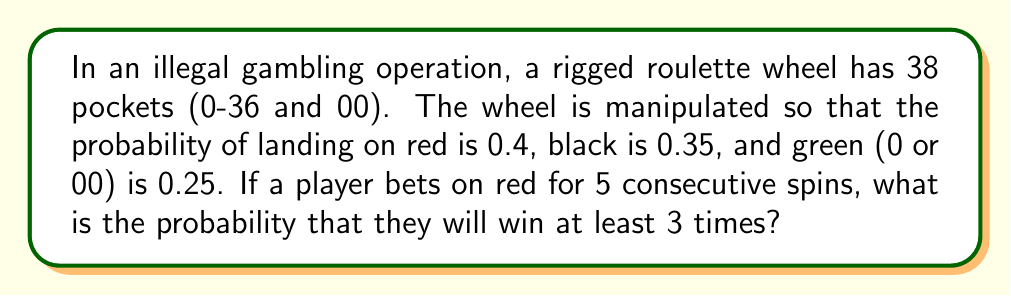Provide a solution to this math problem. Let's approach this step-by-step:

1) First, we need to recognize that this is a binomial probability problem. We're looking for the probability of at least 3 successes in 5 trials.

2) The probability of success (landing on red) on a single spin is 0.4.

3) We need to calculate the probability of exactly 3, 4, or 5 successes in 5 trials and sum these probabilities.

4) The binomial probability formula is:

   $$P(X=k) = \binom{n}{k} p^k (1-p)^{n-k}$$

   Where $n$ is the number of trials, $k$ is the number of successes, $p$ is the probability of success on a single trial.

5) Let's calculate each probability:

   For 3 successes: $$P(X=3) = \binom{5}{3} (0.4)^3 (0.6)^2 = 10 \cdot 0.064 \cdot 0.36 = 0.2304$$

   For 4 successes: $$P(X=4) = \binom{5}{4} (0.4)^4 (0.6)^1 = 5 \cdot 0.0256 \cdot 0.6 = 0.0768$$

   For 5 successes: $$P(X=5) = \binom{5}{5} (0.4)^5 (0.6)^0 = 1 \cdot 0.01024 \cdot 1 = 0.01024$$

6) The probability of at least 3 successes is the sum of these probabilities:

   $$P(X \geq 3) = 0.2304 + 0.0768 + 0.01024 = 0.31744$$
Answer: 0.31744 